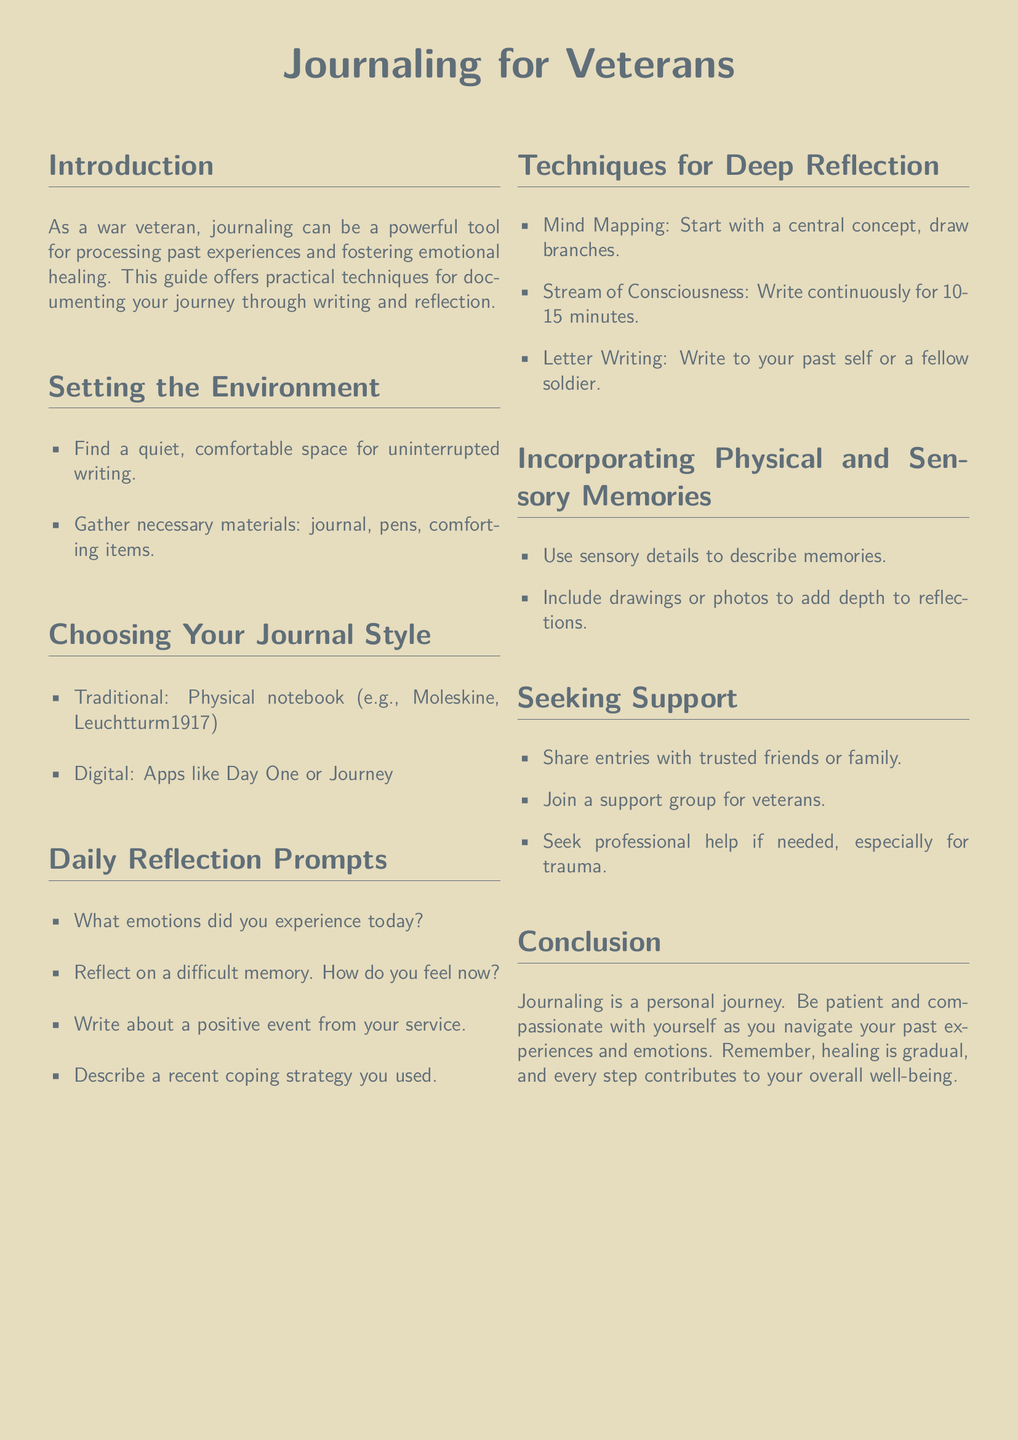What is the title of the document? The title is prominently displayed at the top of the document as a heading.
Answer: Journaling for Veterans What colors are used for the page and text? The document specifies the colors used for both the page background and the text.
Answer: Sandbeige and Marinegray How many reflection prompts are listed in the document? The document enumerates the reflection prompts in a list format.
Answer: Four What is one technique mentioned for deep reflection? The document lists various techniques, each serving as a method for deep reflection.
Answer: Mind Mapping What should you gather before starting your journaling session? The document provides a concise list of items to prepare for journaling.
Answer: Journal, pens, comforting items What type of journal styles are suggested? The document categorizes journal styles into two distinct types.
Answer: Traditional and Digital What is a recommended strategy for seeking support? The document offers various options for seeking support, highlighting their importance.
Answer: Share entries with trusted friends or family What is the overall message of the conclusion? The conclusion provides a reminder of the emotional journey and healing process.
Answer: Healing is gradual Which section discusses sensory memories? The document has specific sections that focus on different journaling techniques.
Answer: Incorporating Physical and Sensory Memories 